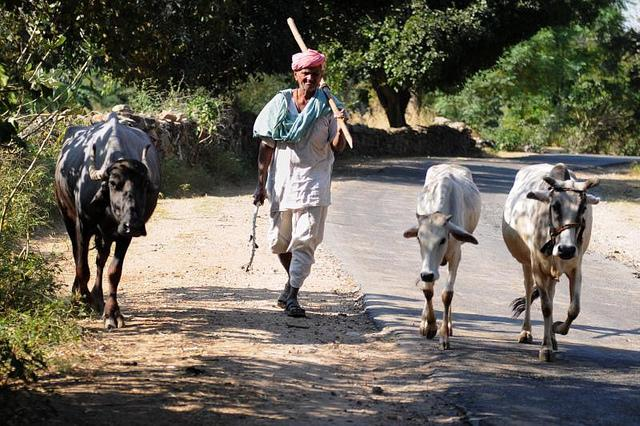How many cows are following around the man in the red turban?

Choices:
A) three
B) two
C) five
D) four three 